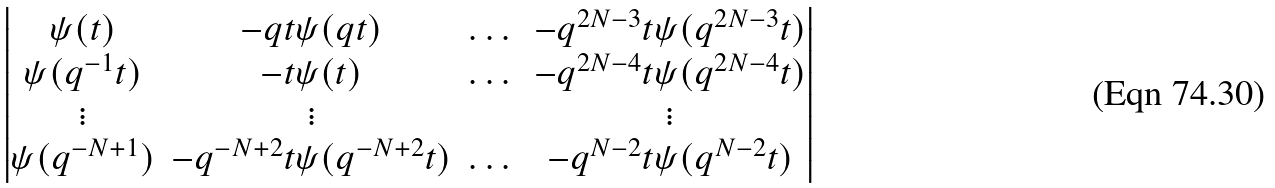<formula> <loc_0><loc_0><loc_500><loc_500>\begin{vmatrix} \psi ( t ) & - q t \psi ( q t ) & \dots & - q ^ { 2 N - 3 } t \psi ( q ^ { 2 N - 3 } t ) \\ \psi ( q ^ { - 1 } t ) & - t \psi ( { t } ) & \dots & - q ^ { 2 N - 4 } t \psi ( q ^ { 2 N - 4 } t ) \\ \vdots & \vdots & \quad & \vdots \\ \psi ( q ^ { - N + 1 } ) & - q ^ { - N + 2 } t \psi ( q ^ { - N + 2 } t ) & \dots & - q ^ { N - 2 } t \psi ( q ^ { N - 2 } t ) \end{vmatrix}</formula> 